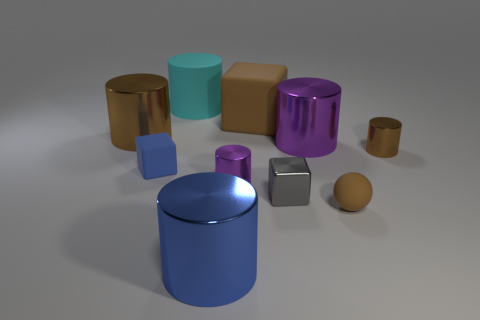There is a rubber thing that is the same color as the rubber sphere; what is its size?
Your answer should be very brief. Large. There is a tiny brown object that is the same shape as the small purple shiny thing; what is its material?
Offer a terse response. Metal. Is the material of the gray cube the same as the large brown cylinder?
Provide a succinct answer. Yes. The tiny metal object that is the same color as the ball is what shape?
Your response must be concise. Cylinder. Do the big shiny object on the left side of the big blue shiny object and the big block have the same color?
Your answer should be compact. Yes. There is a metallic cylinder in front of the tiny purple thing; how many big cyan things are behind it?
Make the answer very short. 1. There is a metal cube that is the same size as the ball; what color is it?
Your answer should be compact. Gray. There is a large object right of the small gray block; what is it made of?
Make the answer very short. Metal. There is a object that is both to the left of the tiny purple cylinder and in front of the small gray metal cube; what material is it made of?
Offer a terse response. Metal. There is a metal cylinder in front of the gray shiny thing; does it have the same size as the tiny blue thing?
Provide a succinct answer. No. 